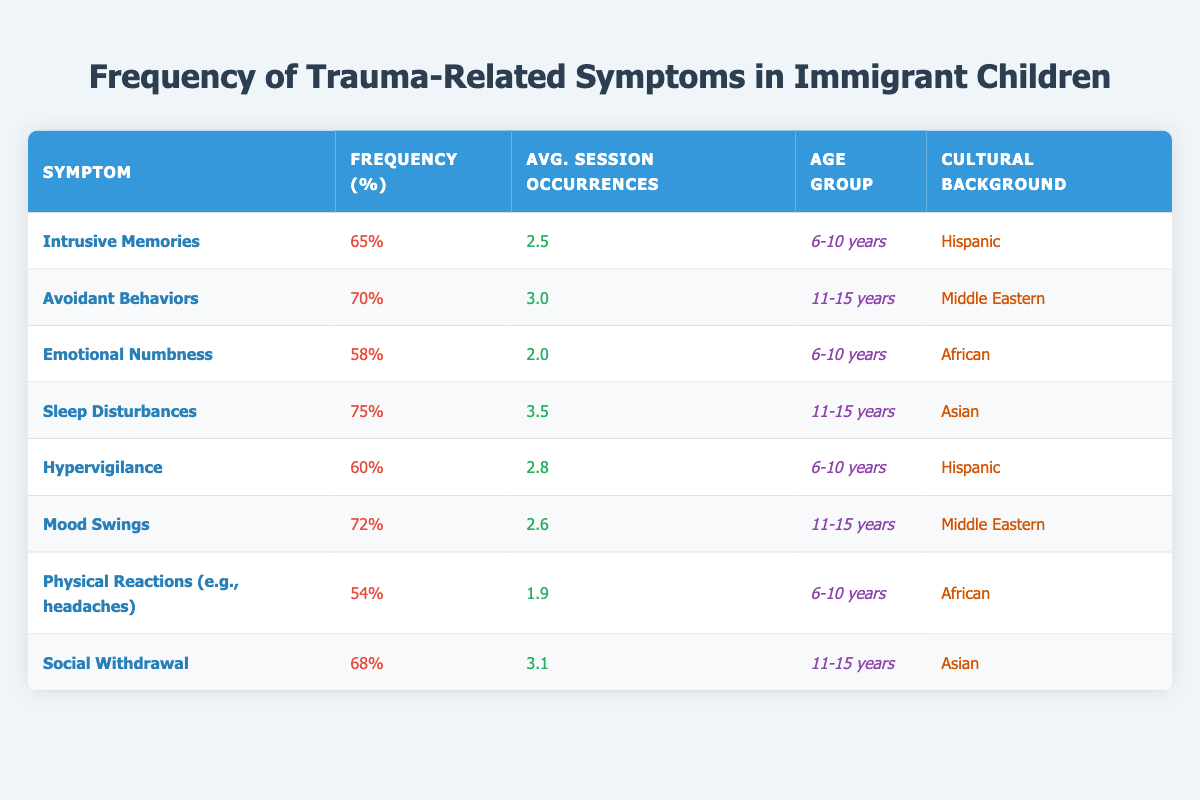What is the frequency percentage of Sleep Disturbances? The table lists the frequency percentage for each symptom. Looking at the "Sleep Disturbances" row, the frequency percentage is clearly stated as 75%.
Answer: 75% Which cultural background has the highest frequency of Avoidant Behaviors? The "Avoidant Behaviors" symptom lists a frequency of 70% for the "Middle Eastern" cultural background, which is the highest compared to others in the table.
Answer: Middle Eastern How many average occurrences of Emotional Numbness are reported during therapy sessions for children aged 6-10 years? The table states that for "Emotional Numbness," the average session occurrences is displayed as 2.0 for the age group of 6-10 years.
Answer: 2.0 Is there a symptom with a frequency percentage lower than 55%? Looking through the frequency percentages in the table, the lowest recorded is 54% for "Physical Reactions." Since this is less than 55%, the statement is true.
Answer: Yes What is the average frequency percentage for symptoms reported by children aged 11-15 years? First, identify the percentage for each symptom in the 11-15 age group: 70% (Avoidant Behaviors), 75% (Sleep Disturbances), 72% (Mood Swings), and 68% (Social Withdrawal). Adding these gives 70 + 75 + 72 + 68 = 285. Divide by the number of symptoms (4) to get the average frequency percentage: 285/4 = 71.25%.
Answer: 71.25% Which symptom reported by children aged 6-10 has the lowest average session occurrences? For the 6-10 age group, the symptoms and their average occurrences are: Intrusive Memories (2.5), Emotional Numbness (2.0), Hypervigilance (2.8), and Physical Reactions (1.9). The lowest in this list is 1.9 for "Physical Reactions."
Answer: Physical Reactions Are sleep disturbances reported more frequently in children aged 11-15 years than intrusive memories in children aged 6-10 years? The frequency percentage for "Sleep Disturbances" in the 11-15 age group is 75%, while "Intrusive Memories" in the 6-10 age group has a frequency of 65%. Thus, sleep disturbances are reported more frequently.
Answer: Yes What is the difference in frequency percentage between Mood Swings and Emotional Numbness? The frequency for Mood Swings is 72% and for Emotional Numbness is 58%. The difference can be calculated by subtracting: 72 - 58 = 14%.
Answer: 14% 